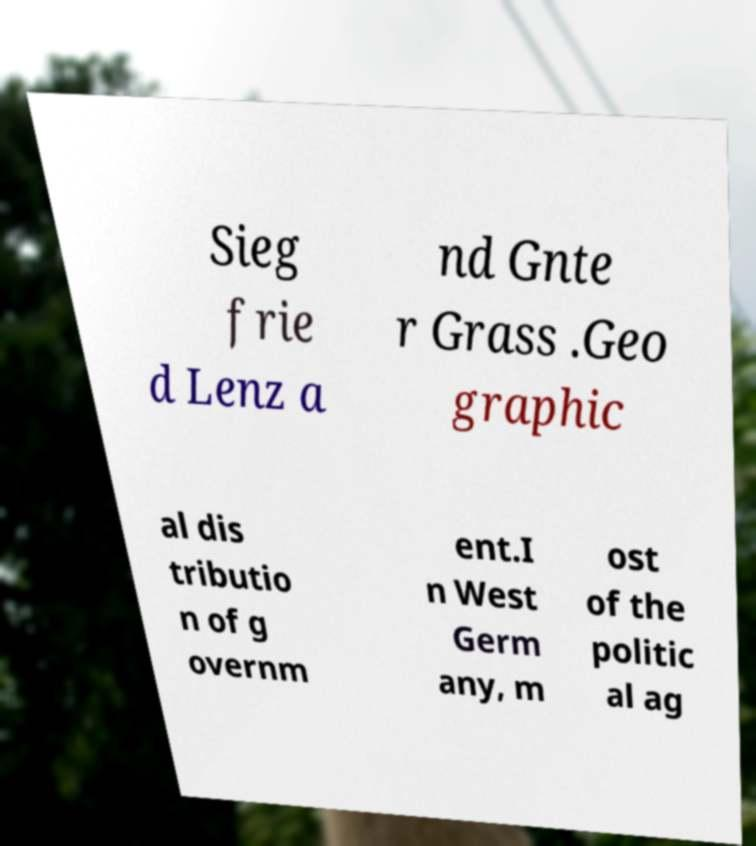Can you read and provide the text displayed in the image?This photo seems to have some interesting text. Can you extract and type it out for me? Sieg frie d Lenz a nd Gnte r Grass .Geo graphic al dis tributio n of g overnm ent.I n West Germ any, m ost of the politic al ag 